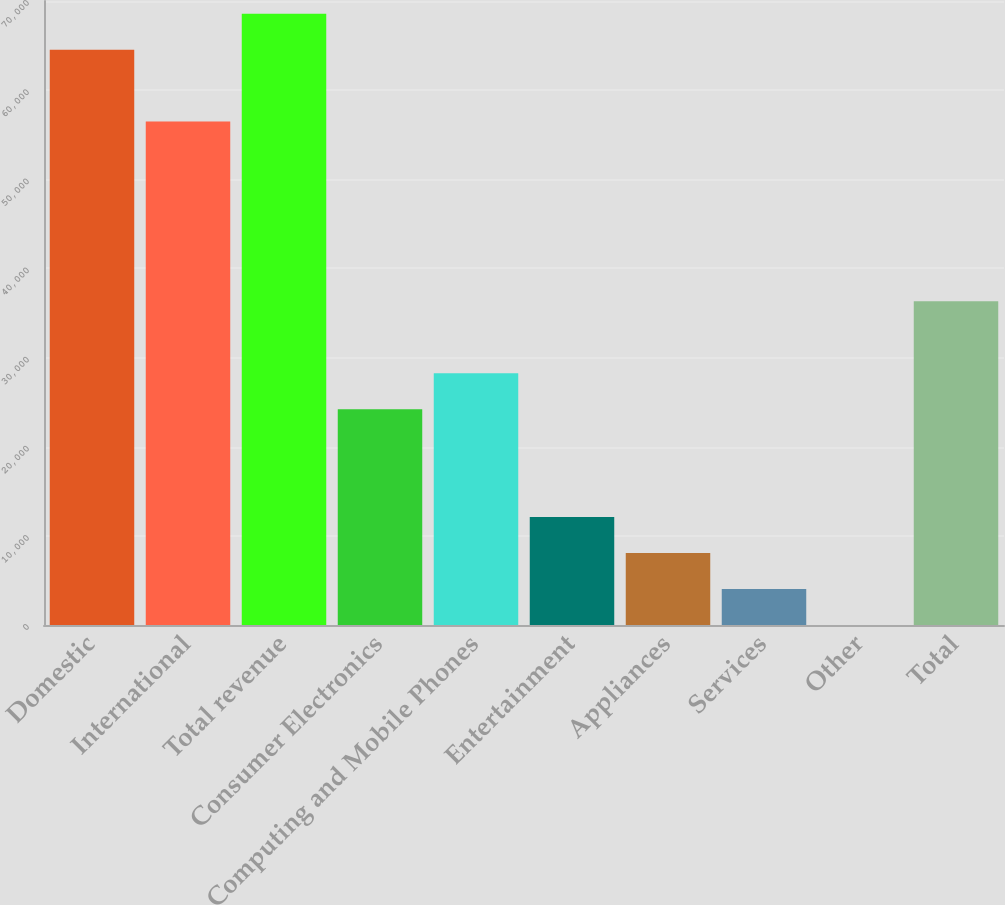<chart> <loc_0><loc_0><loc_500><loc_500><bar_chart><fcel>Domestic<fcel>International<fcel>Total revenue<fcel>Consumer Electronics<fcel>Computing and Mobile Phones<fcel>Entertainment<fcel>Appliances<fcel>Services<fcel>Other<fcel>Total<nl><fcel>64541.8<fcel>56474.2<fcel>68575.6<fcel>24203.8<fcel>28237.6<fcel>12102.4<fcel>8068.6<fcel>4034.8<fcel>1<fcel>36305.2<nl></chart> 